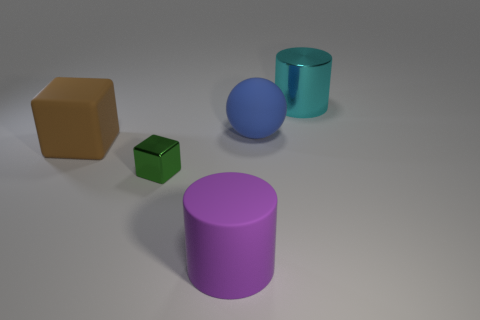Add 1 red matte objects. How many objects exist? 6 Subtract all cubes. How many objects are left? 3 Add 1 blue rubber spheres. How many blue rubber spheres are left? 2 Add 1 rubber cylinders. How many rubber cylinders exist? 2 Subtract 0 red cubes. How many objects are left? 5 Subtract all large green shiny cylinders. Subtract all balls. How many objects are left? 4 